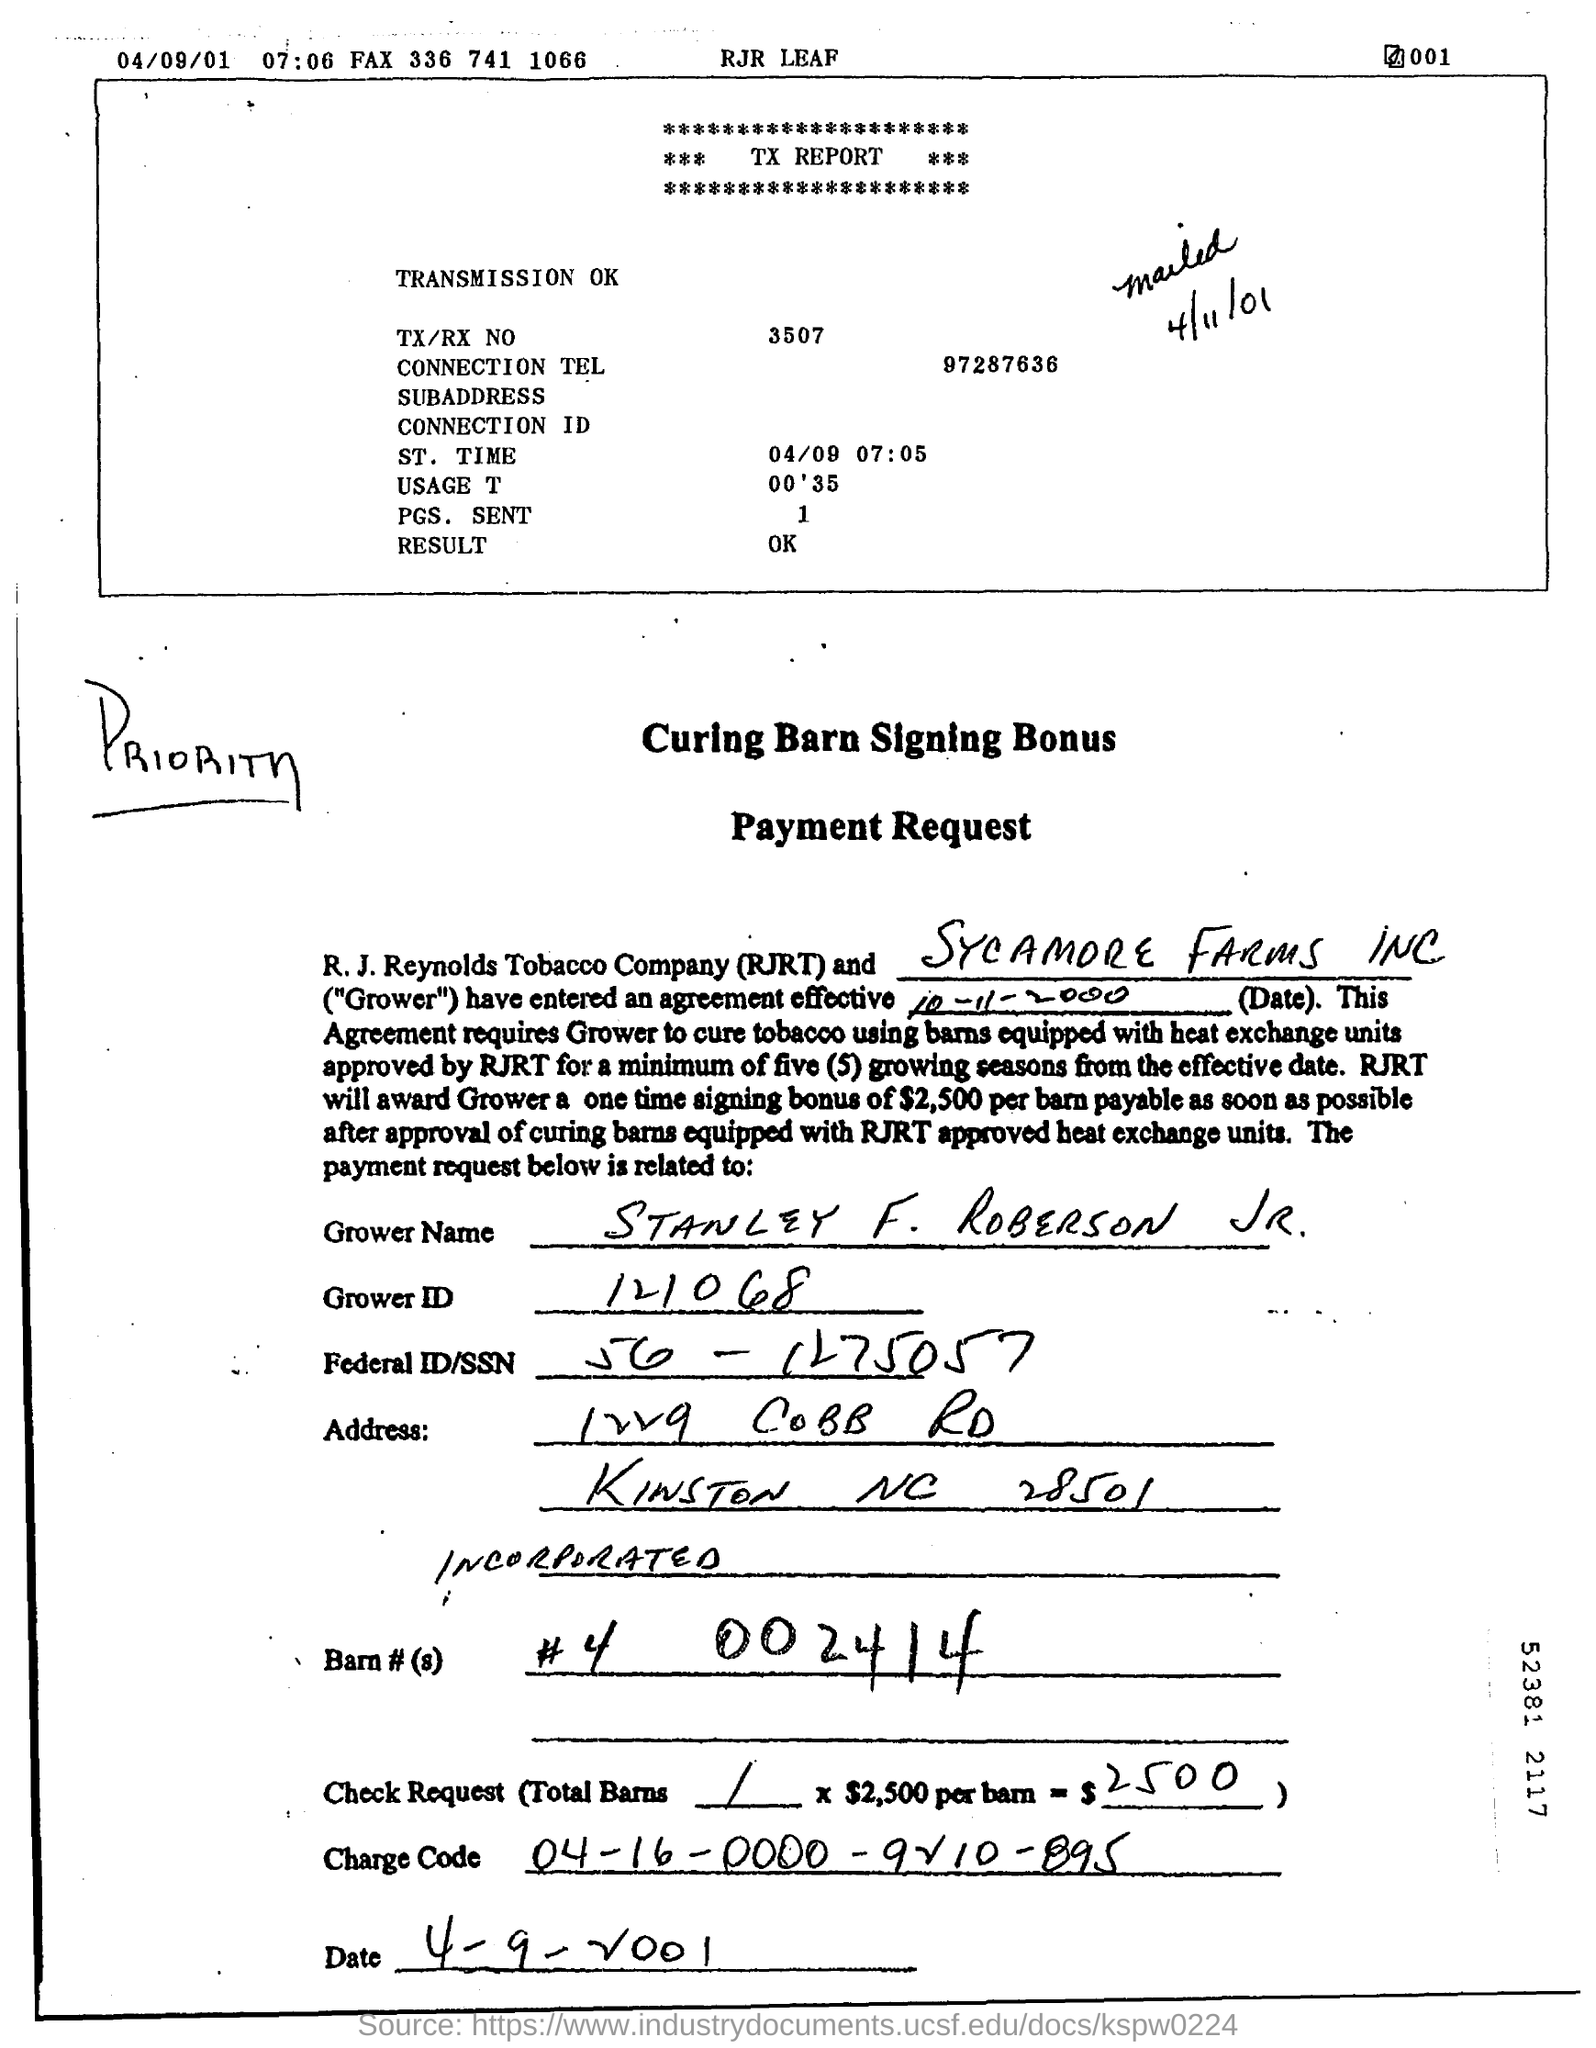Outline some significant characteristics in this image. The charge code '04-16-0000-9210-895' refers to a specific financial transaction or charge, the details of which are confidential and subject to protection. RJRT will provide a one-time signing bonus of $2,500 to the Grower. The TX/RX NO mentioned in the TX report is 3507. The Grower ID is a unique identification number that is assigned to a specific grower, such as 121068. 